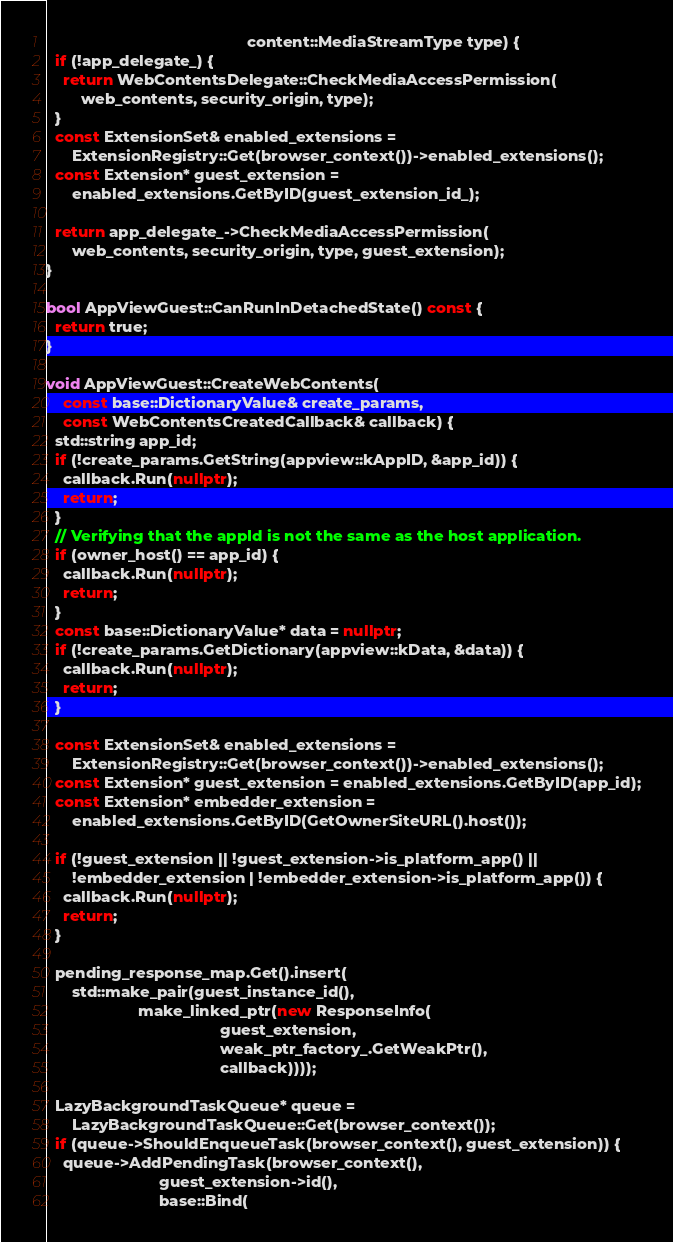Convert code to text. <code><loc_0><loc_0><loc_500><loc_500><_C++_>                                              content::MediaStreamType type) {
  if (!app_delegate_) {
    return WebContentsDelegate::CheckMediaAccessPermission(
        web_contents, security_origin, type);
  }
  const ExtensionSet& enabled_extensions =
      ExtensionRegistry::Get(browser_context())->enabled_extensions();
  const Extension* guest_extension =
      enabled_extensions.GetByID(guest_extension_id_);

  return app_delegate_->CheckMediaAccessPermission(
      web_contents, security_origin, type, guest_extension);
}

bool AppViewGuest::CanRunInDetachedState() const {
  return true;
}

void AppViewGuest::CreateWebContents(
    const base::DictionaryValue& create_params,
    const WebContentsCreatedCallback& callback) {
  std::string app_id;
  if (!create_params.GetString(appview::kAppID, &app_id)) {
    callback.Run(nullptr);
    return;
  }
  // Verifying that the appId is not the same as the host application.
  if (owner_host() == app_id) {
    callback.Run(nullptr);
    return;
  }
  const base::DictionaryValue* data = nullptr;
  if (!create_params.GetDictionary(appview::kData, &data)) {
    callback.Run(nullptr);
    return;
  }

  const ExtensionSet& enabled_extensions =
      ExtensionRegistry::Get(browser_context())->enabled_extensions();
  const Extension* guest_extension = enabled_extensions.GetByID(app_id);
  const Extension* embedder_extension =
      enabled_extensions.GetByID(GetOwnerSiteURL().host());

  if (!guest_extension || !guest_extension->is_platform_app() ||
      !embedder_extension | !embedder_extension->is_platform_app()) {
    callback.Run(nullptr);
    return;
  }

  pending_response_map.Get().insert(
      std::make_pair(guest_instance_id(),
                     make_linked_ptr(new ResponseInfo(
                                        guest_extension,
                                        weak_ptr_factory_.GetWeakPtr(),
                                        callback))));

  LazyBackgroundTaskQueue* queue =
      LazyBackgroundTaskQueue::Get(browser_context());
  if (queue->ShouldEnqueueTask(browser_context(), guest_extension)) {
    queue->AddPendingTask(browser_context(),
                          guest_extension->id(),
                          base::Bind(</code> 